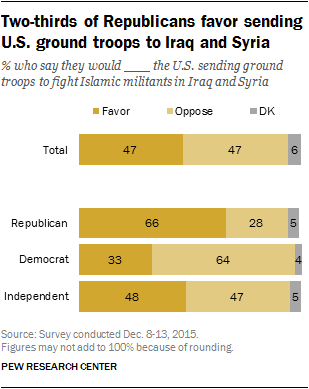Mention a couple of crucial points in this snapshot. The difference between the preferred distribution among Democrats and Independents is 15.. There are three colors in the bar. 